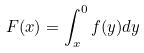Convert formula to latex. <formula><loc_0><loc_0><loc_500><loc_500>F ( x ) = \int _ { x } ^ { 0 } f ( y ) d y</formula> 